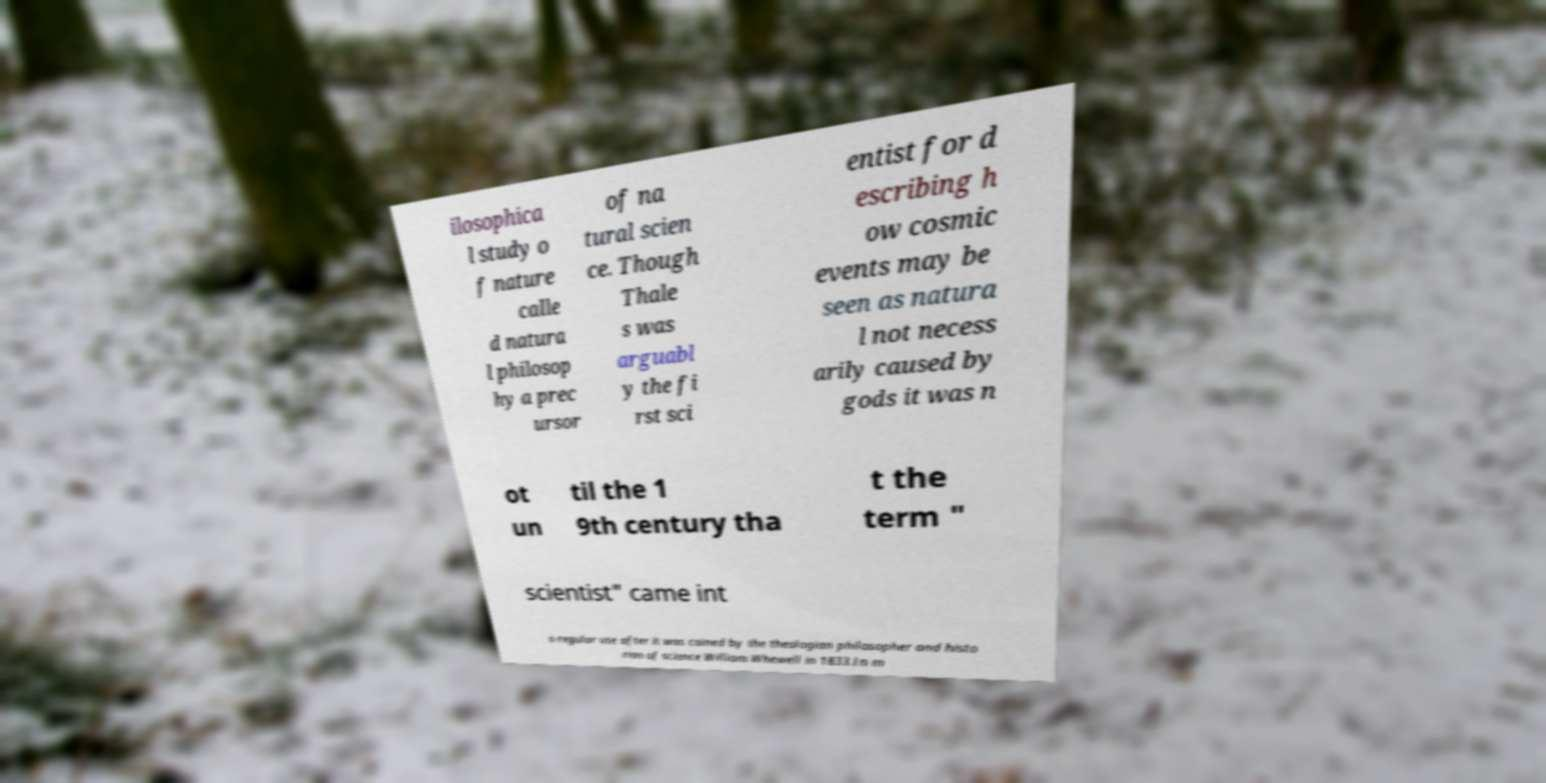Could you extract and type out the text from this image? ilosophica l study o f nature calle d natura l philosop hy a prec ursor of na tural scien ce. Though Thale s was arguabl y the fi rst sci entist for d escribing h ow cosmic events may be seen as natura l not necess arily caused by gods it was n ot un til the 1 9th century tha t the term " scientist" came int o regular use after it was coined by the theologian philosopher and histo rian of science William Whewell in 1833.In m 